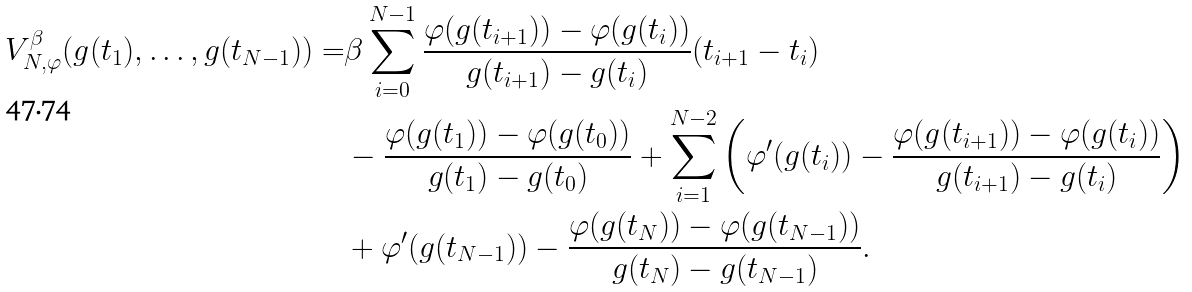<formula> <loc_0><loc_0><loc_500><loc_500>V _ { N , \varphi } ^ { \beta } ( g ( t _ { 1 } ) , \dots , g ( t _ { N - 1 } ) ) = & \beta \sum _ { i = 0 } ^ { N - 1 } \frac { \varphi ( g ( t _ { i + 1 } ) ) - \varphi ( g ( t _ { i } ) ) } { g ( t _ { i + 1 } ) - g ( t _ { i } ) } ( t _ { i + 1 } - t _ { i } ) \\ & - \frac { \varphi ( g ( t _ { 1 } ) ) - \varphi ( g ( t _ { 0 } ) ) } { g ( t _ { 1 } ) - g ( t _ { 0 } ) } + \sum _ { i = 1 } ^ { N - 2 } \left ( \varphi ^ { \prime } ( g ( t _ { i } ) ) - \frac { \varphi ( g ( t _ { i + 1 } ) ) - \varphi ( g ( t _ { i } ) ) } { g ( t _ { i + 1 } ) - g ( t _ { i } ) } \right ) \\ & + \varphi ^ { \prime } ( g ( t _ { N - 1 } ) ) - \frac { \varphi ( g ( t _ { N } ) ) - \varphi ( g ( t _ { N - 1 } ) ) } { g ( t _ { N } ) - g ( t _ { N - 1 } ) } .</formula> 